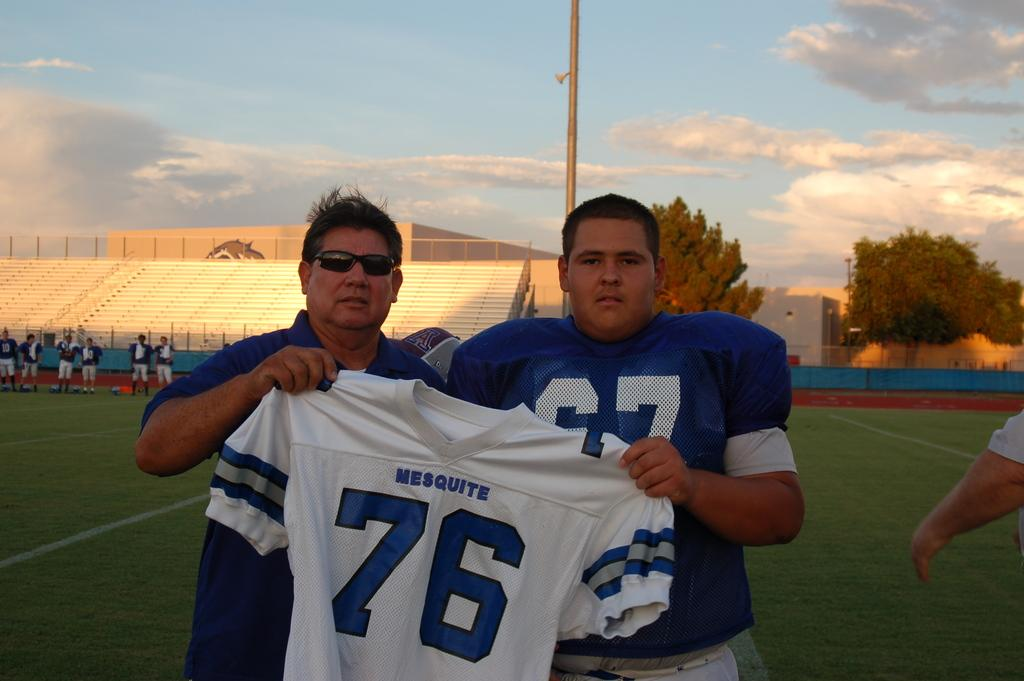<image>
Write a terse but informative summary of the picture. Two men in blue proudly hold up the number 76 jersey. 